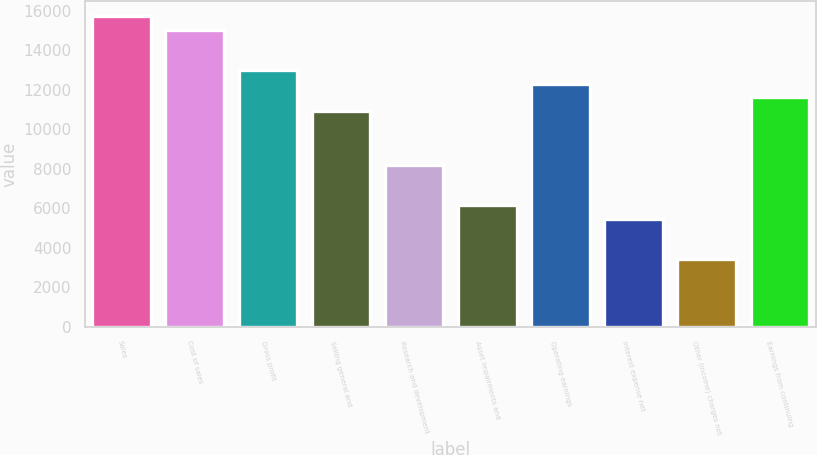Convert chart to OTSL. <chart><loc_0><loc_0><loc_500><loc_500><bar_chart><fcel>Sales<fcel>Cost of sales<fcel>Gross profit<fcel>Selling general and<fcel>Research and development<fcel>Asset impairments and<fcel>Operating earnings<fcel>Interest expense net<fcel>Other (income) charges net<fcel>Earnings from continuing<nl><fcel>15708.6<fcel>15025.6<fcel>12976.7<fcel>10927.8<fcel>8195.9<fcel>6146.99<fcel>12293.7<fcel>5464.02<fcel>3415.11<fcel>11610.8<nl></chart> 